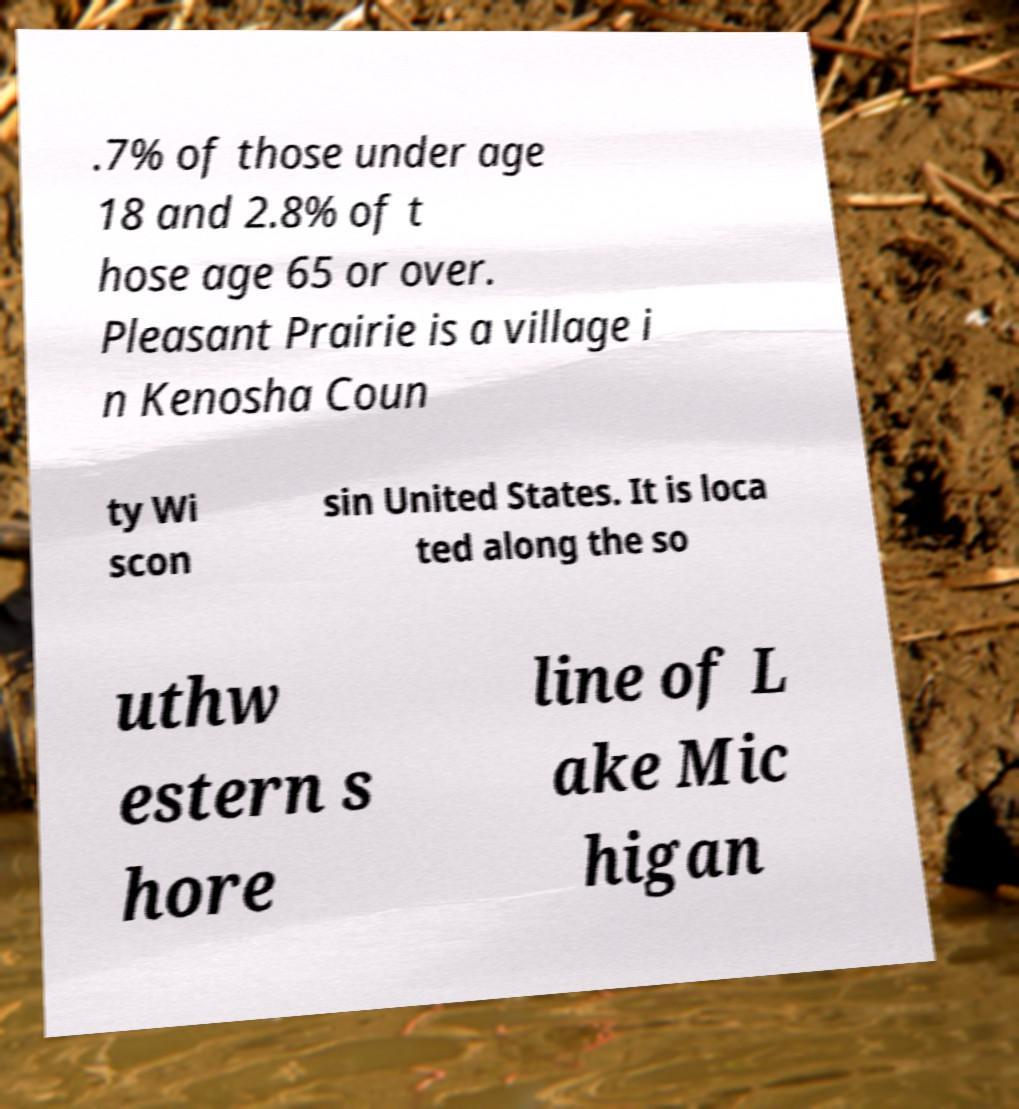What messages or text are displayed in this image? I need them in a readable, typed format. .7% of those under age 18 and 2.8% of t hose age 65 or over. Pleasant Prairie is a village i n Kenosha Coun ty Wi scon sin United States. It is loca ted along the so uthw estern s hore line of L ake Mic higan 